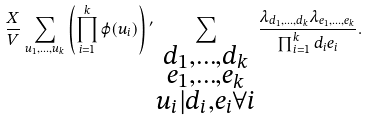<formula> <loc_0><loc_0><loc_500><loc_500>\frac { X } { V } \sum _ { u _ { 1 } , \dots , u _ { k } } \left ( \prod _ { i = 1 } ^ { k } \varphi ( u _ { i } ) \right ) { ^ { \prime } } \sum _ { \substack { d _ { 1 } , \dots , d _ { k } \\ e _ { 1 } , \dots , e _ { k } \\ u _ { i } | d _ { i } , e _ { i } \forall i } } \frac { \lambda _ { d _ { 1 } , \dots , d _ { k } } \lambda _ { e _ { 1 } , \dots , e _ { k } } } { \prod _ { i = 1 } ^ { k } d _ { i } e _ { i } } .</formula> 